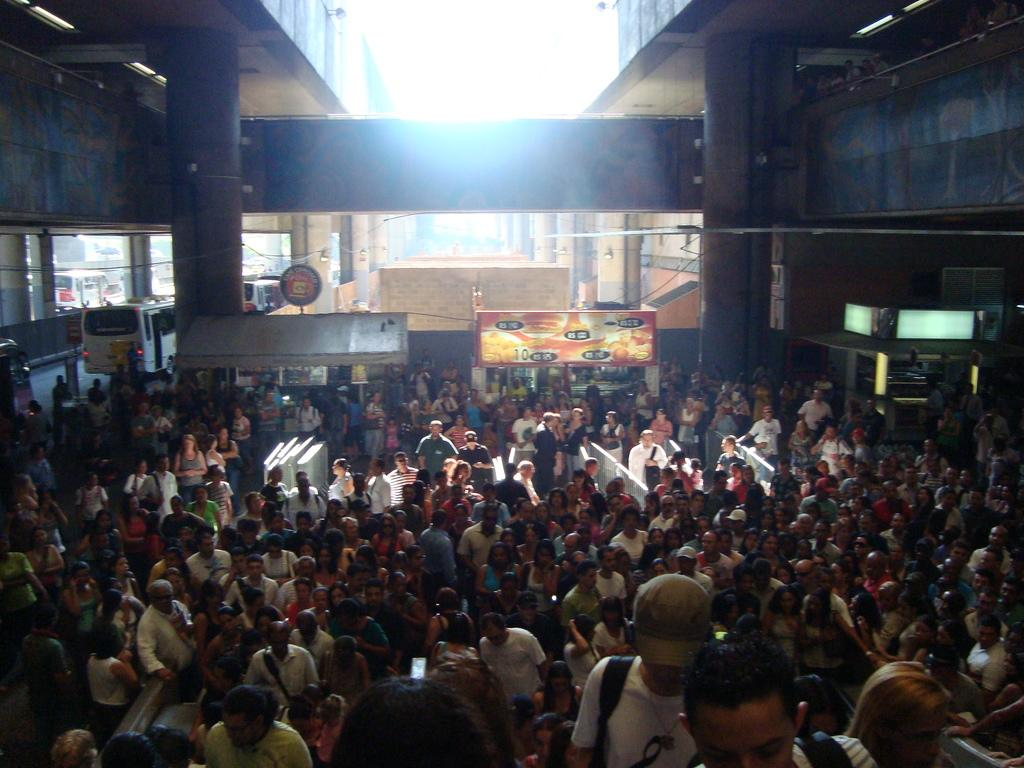How many people can be seen in the image? There are many people standing in the image. What can be seen in the background of the image? There are stalls and vehicles moving in the background of the image. What architectural feature is present in the image? There are pillars associated with a wall in the image. What type of spark can be seen coming from the ghost in the image? There is no ghost or spark present in the image. What book is the person reading in the image? There is no book or person reading in the image. 